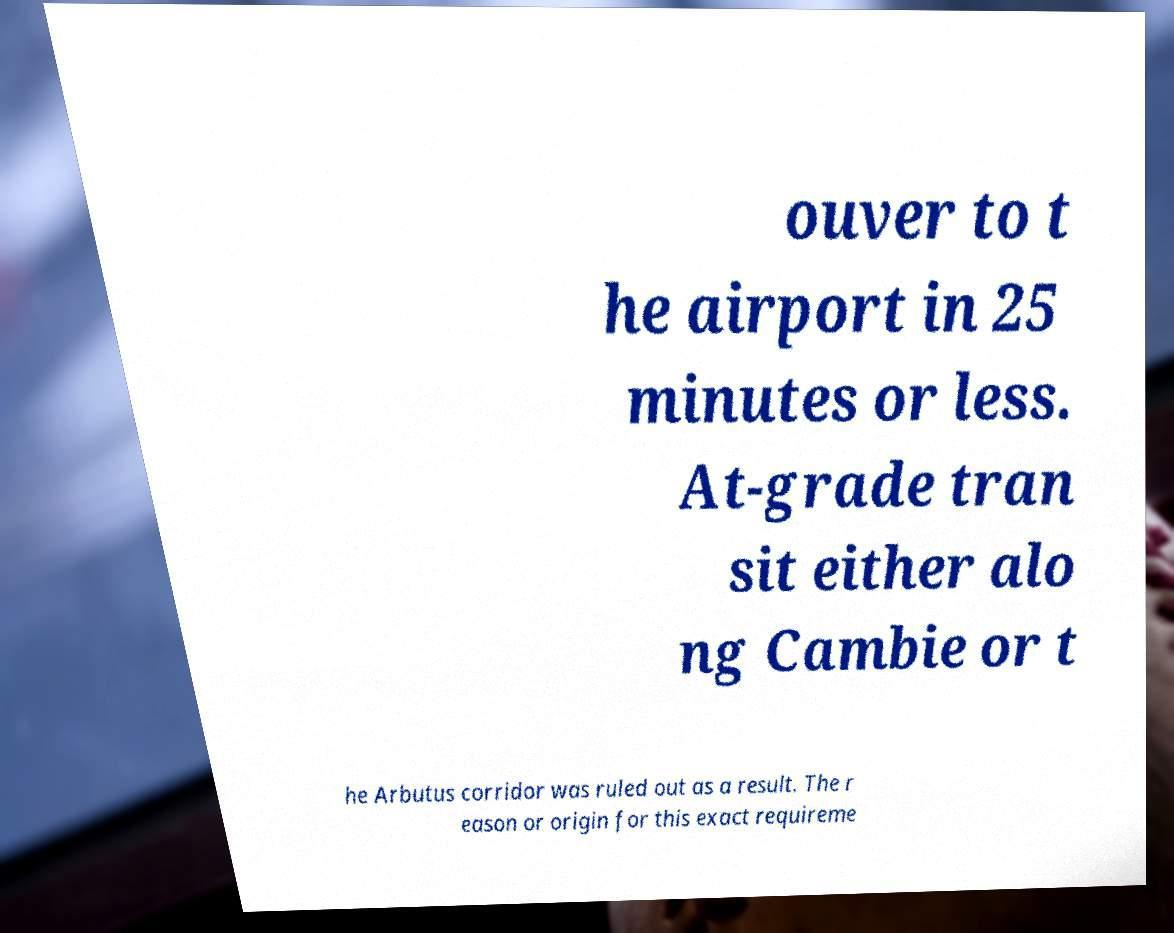What messages or text are displayed in this image? I need them in a readable, typed format. ouver to t he airport in 25 minutes or less. At-grade tran sit either alo ng Cambie or t he Arbutus corridor was ruled out as a result. The r eason or origin for this exact requireme 